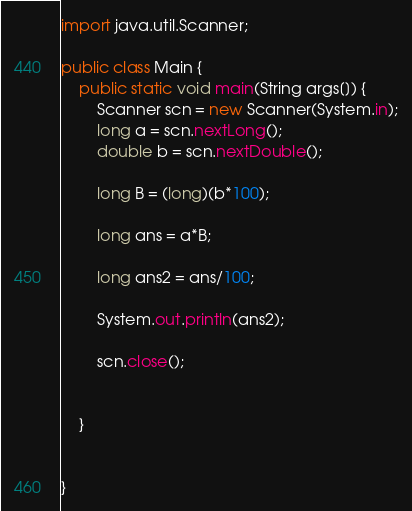<code> <loc_0><loc_0><loc_500><loc_500><_Java_>import java.util.Scanner;

public class Main {
    public static void main(String args[]) {
        Scanner scn = new Scanner(System.in);
        long a = scn.nextLong();
        double b = scn.nextDouble();

        long B = (long)(b*100);

        long ans = a*B;

        long ans2 = ans/100;

        System.out.println(ans2);

        scn.close();


    }


}</code> 